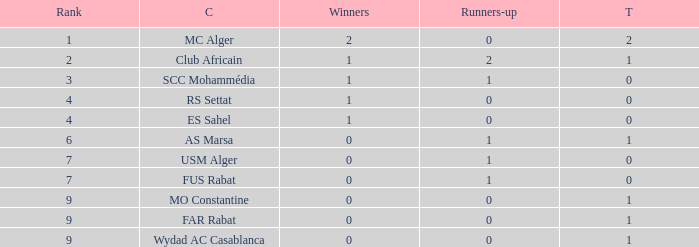Which Rank has a Third of 2, and Winners smaller than 2? None. Help me parse the entirety of this table. {'header': ['Rank', 'C', 'Winners', 'Runners-up', 'T'], 'rows': [['1', 'MC Alger', '2', '0', '2'], ['2', 'Club Africain', '1', '2', '1'], ['3', 'SCC Mohammédia', '1', '1', '0'], ['4', 'RS Settat', '1', '0', '0'], ['4', 'ES Sahel', '1', '0', '0'], ['6', 'AS Marsa', '0', '1', '1'], ['7', 'USM Alger', '0', '1', '0'], ['7', 'FUS Rabat', '0', '1', '0'], ['9', 'MO Constantine', '0', '0', '1'], ['9', 'FAR Rabat', '0', '0', '1'], ['9', 'Wydad AC Casablanca', '0', '0', '1']]} 